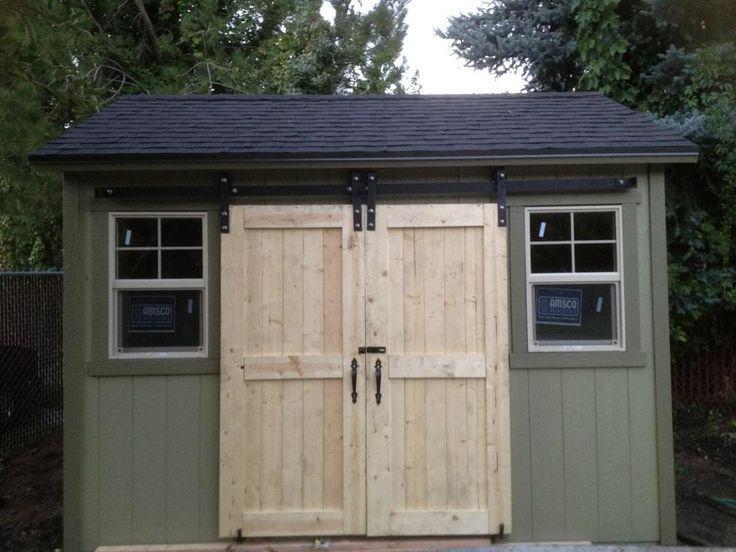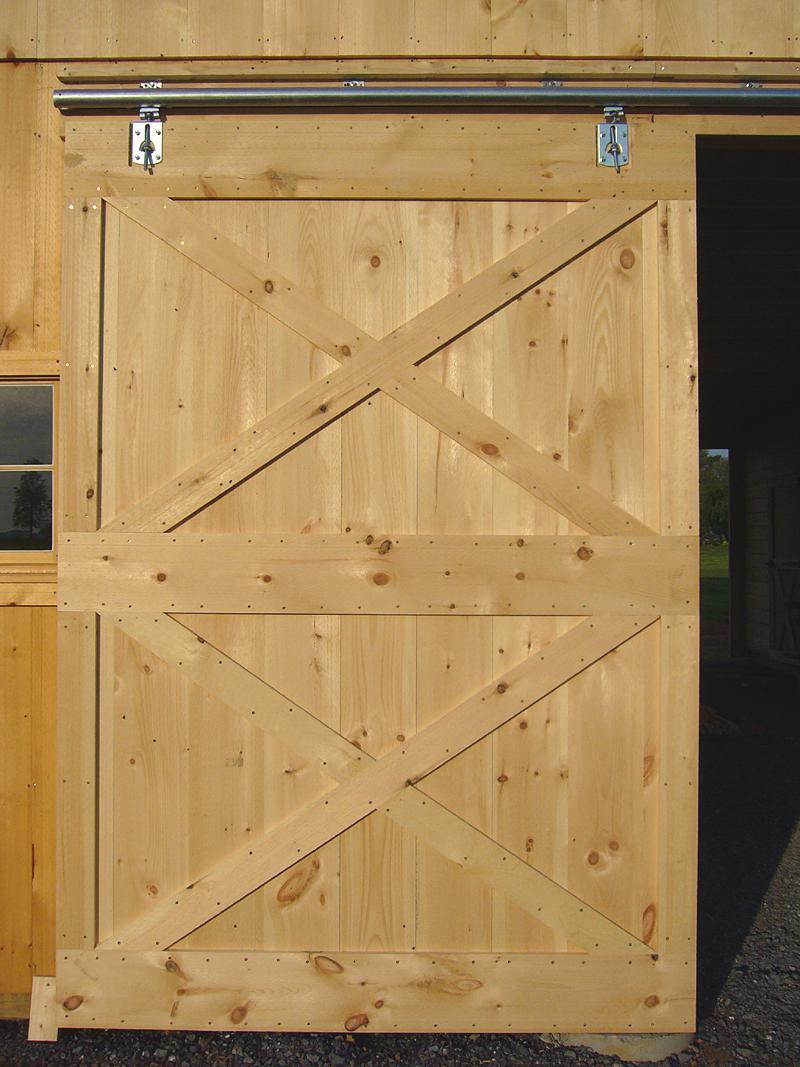The first image is the image on the left, the second image is the image on the right. Analyze the images presented: Is the assertion "An image depicts a barn door with diagonal crossed boards on the front." valid? Answer yes or no. Yes. 